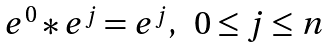Convert formula to latex. <formula><loc_0><loc_0><loc_500><loc_500>\begin{array} { l r } e ^ { 0 } * e ^ { j } = e ^ { j } , & 0 \leq j \leq n \\ \end{array}</formula> 